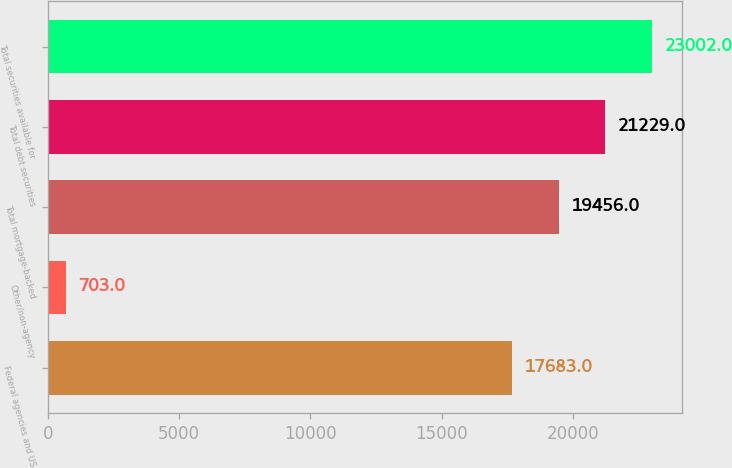<chart> <loc_0><loc_0><loc_500><loc_500><bar_chart><fcel>Federal agencies and US<fcel>Other/non-agency<fcel>Total mortgage-backed<fcel>Total debt securities<fcel>Total securities available for<nl><fcel>17683<fcel>703<fcel>19456<fcel>21229<fcel>23002<nl></chart> 